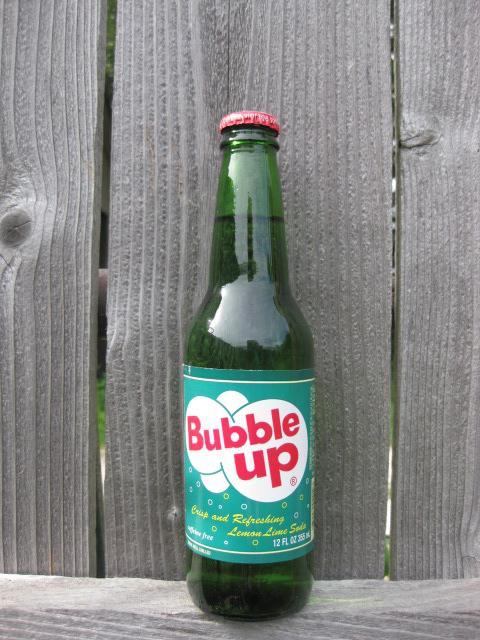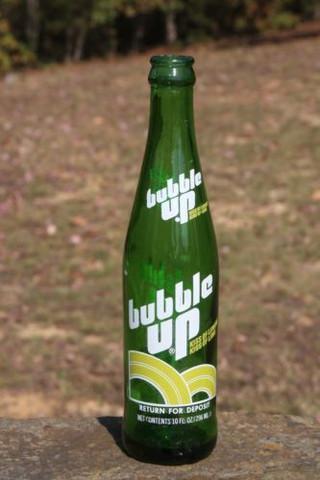The first image is the image on the left, the second image is the image on the right. Given the left and right images, does the statement "Has atleast one picture of a drink that isn't Bubble Up" hold true? Answer yes or no. No. The first image is the image on the left, the second image is the image on the right. Assess this claim about the two images: "Each image contains a single green glass soda bottle, and at least one bottle depicted has overlapping white circle shapes on its front.". Correct or not? Answer yes or no. Yes. 